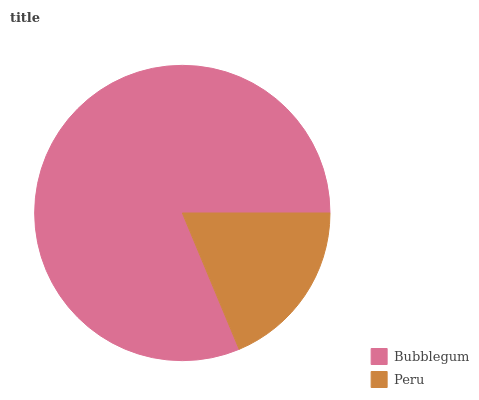Is Peru the minimum?
Answer yes or no. Yes. Is Bubblegum the maximum?
Answer yes or no. Yes. Is Peru the maximum?
Answer yes or no. No. Is Bubblegum greater than Peru?
Answer yes or no. Yes. Is Peru less than Bubblegum?
Answer yes or no. Yes. Is Peru greater than Bubblegum?
Answer yes or no. No. Is Bubblegum less than Peru?
Answer yes or no. No. Is Bubblegum the high median?
Answer yes or no. Yes. Is Peru the low median?
Answer yes or no. Yes. Is Peru the high median?
Answer yes or no. No. Is Bubblegum the low median?
Answer yes or no. No. 